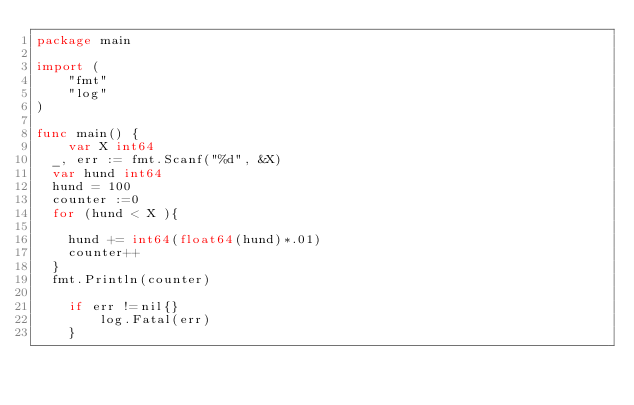Convert code to text. <code><loc_0><loc_0><loc_500><loc_500><_Go_>package main

import (
	"fmt"
	"log"
)

func main() {
	var X int64
  _, err := fmt.Scanf("%d", &X)
  var hund int64
  hund = 100
  counter :=0
  for (hund < X ){
    
    hund += int64(float64(hund)*.01)
    counter++
  }
  fmt.Println(counter)

	if err !=nil{}
		log.Fatal(err)
	}
</code> 